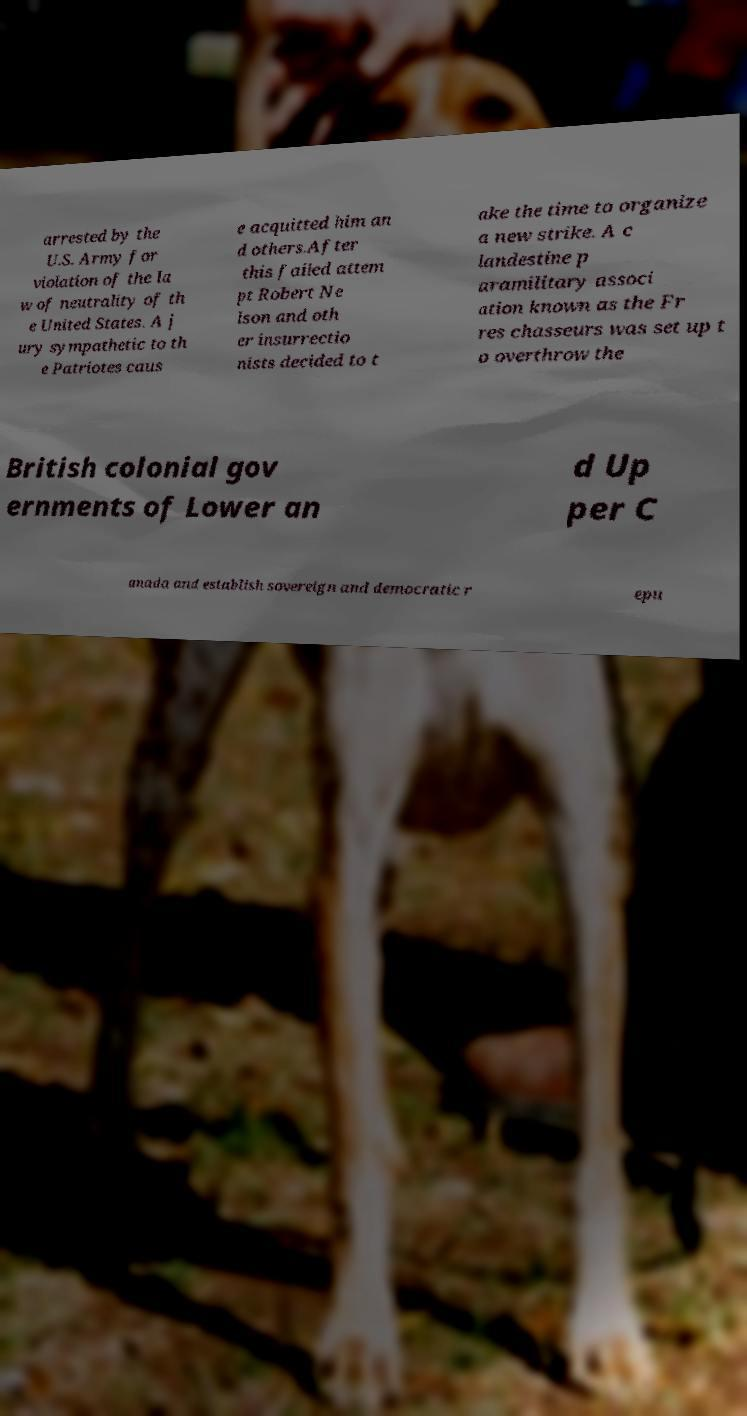I need the written content from this picture converted into text. Can you do that? arrested by the U.S. Army for violation of the la w of neutrality of th e United States. A j ury sympathetic to th e Patriotes caus e acquitted him an d others.After this failed attem pt Robert Ne lson and oth er insurrectio nists decided to t ake the time to organize a new strike. A c landestine p aramilitary associ ation known as the Fr res chasseurs was set up t o overthrow the British colonial gov ernments of Lower an d Up per C anada and establish sovereign and democratic r epu 